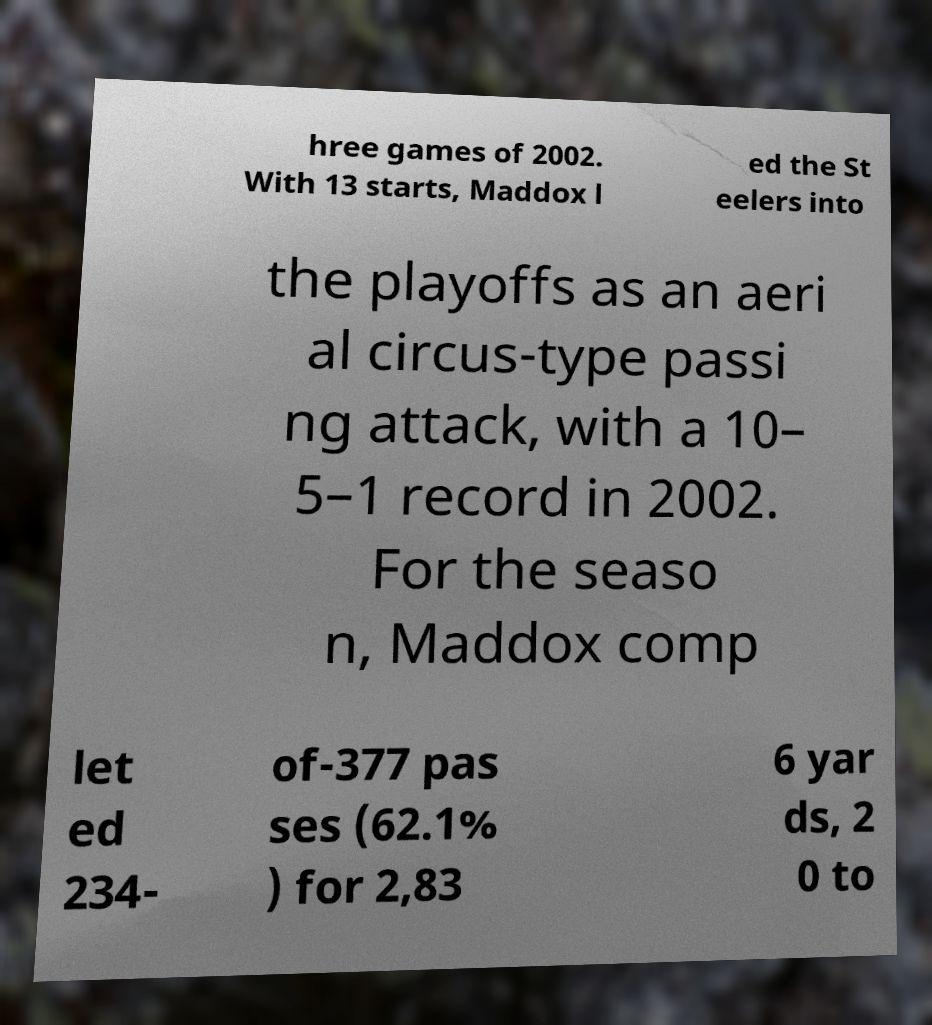For documentation purposes, I need the text within this image transcribed. Could you provide that? hree games of 2002. With 13 starts, Maddox l ed the St eelers into the playoffs as an aeri al circus-type passi ng attack, with a 10– 5–1 record in 2002. For the seaso n, Maddox comp let ed 234- of-377 pas ses (62.1% ) for 2,83 6 yar ds, 2 0 to 